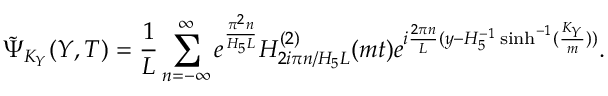<formula> <loc_0><loc_0><loc_500><loc_500>\tilde { \Psi } _ { K _ { Y } } ( Y , T ) = \frac { 1 } { L } \sum _ { n = - \infty } ^ { \infty } e ^ { \frac { \pi ^ { 2 } n } { H _ { 5 } L } } H _ { 2 i \pi n / H _ { 5 } L } ^ { ( 2 ) } ( m t ) e ^ { i { \frac { 2 \pi n } { L } } ( y - H _ { 5 } ^ { - 1 } \sinh ^ { - 1 } ( \frac { K _ { Y } } { m } ) ) } .</formula> 